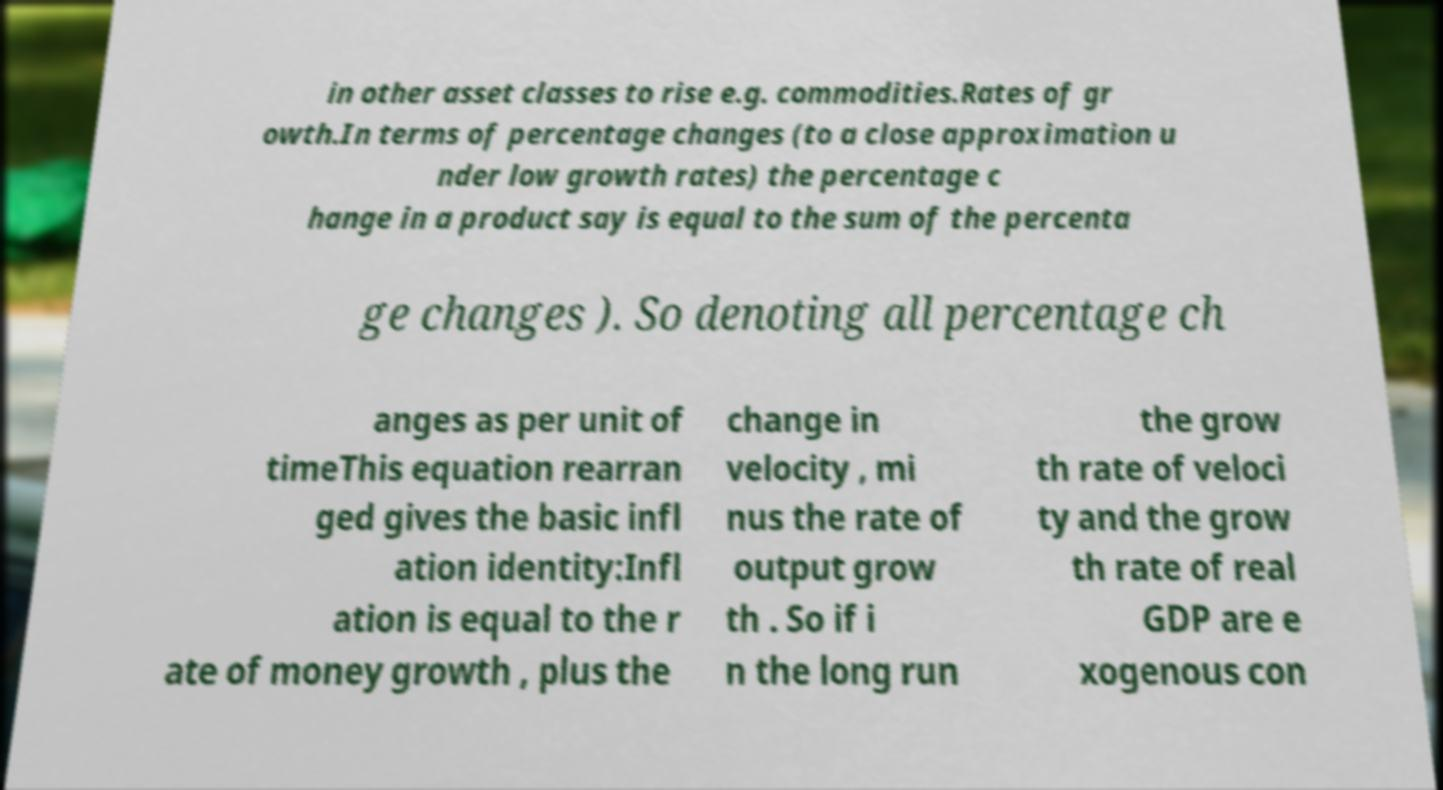Can you accurately transcribe the text from the provided image for me? in other asset classes to rise e.g. commodities.Rates of gr owth.In terms of percentage changes (to a close approximation u nder low growth rates) the percentage c hange in a product say is equal to the sum of the percenta ge changes ). So denoting all percentage ch anges as per unit of timeThis equation rearran ged gives the basic infl ation identity:Infl ation is equal to the r ate of money growth , plus the change in velocity , mi nus the rate of output grow th . So if i n the long run the grow th rate of veloci ty and the grow th rate of real GDP are e xogenous con 